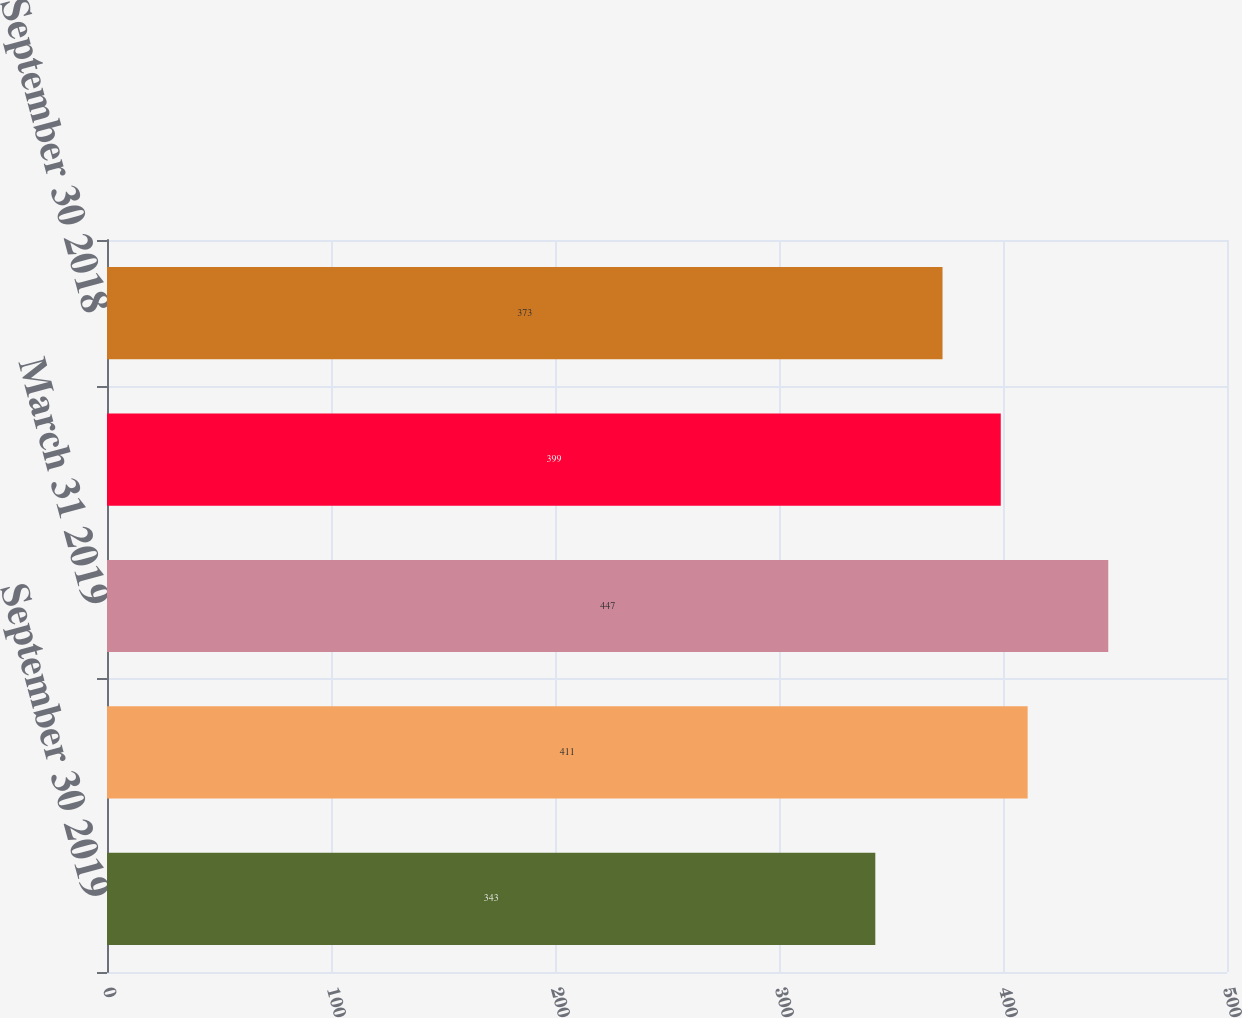Convert chart to OTSL. <chart><loc_0><loc_0><loc_500><loc_500><bar_chart><fcel>September 30 2019<fcel>June 30 2019<fcel>March 31 2019<fcel>December 31 2018<fcel>September 30 2018<nl><fcel>343<fcel>411<fcel>447<fcel>399<fcel>373<nl></chart> 